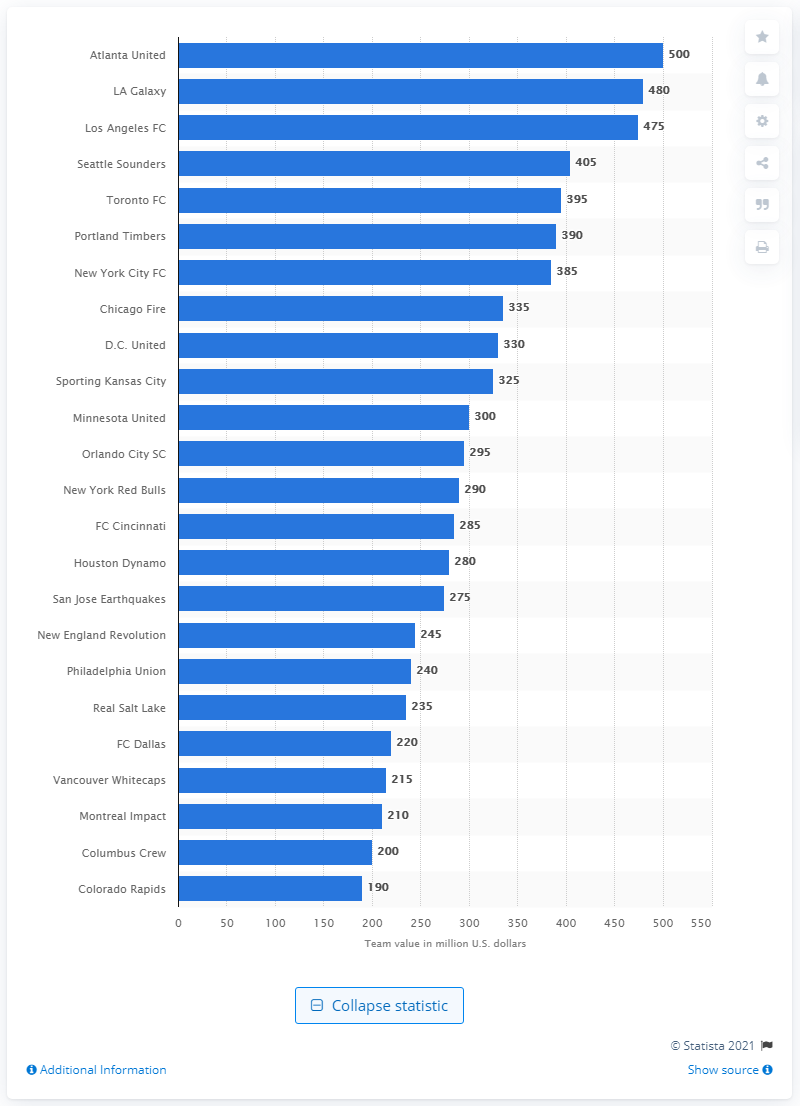Draw attention to some important aspects in this diagram. Atlanta United was the most valuable Major League Soccer team in 2019. In 2019, the value of Atlanta United was estimated to be approximately $500 million. 